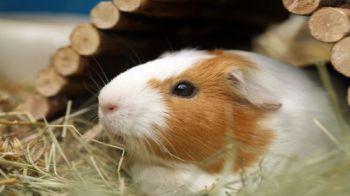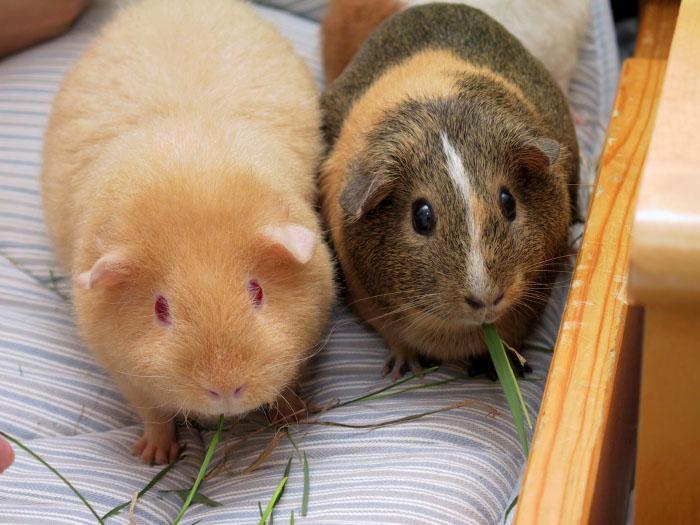The first image is the image on the left, the second image is the image on the right. Examine the images to the left and right. Is the description "The hamster on the right is depicted with produce-type food." accurate? Answer yes or no. No. 